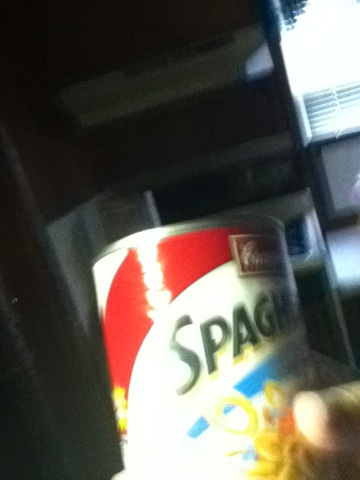Can you tell me more about the nutritional value of this canned spaghetti? Canned spaghetti typically contains carbohydrates from the pasta, some proteins, and fats. Additionally, it is usually rich in vitamins such as Vitamin A and Vitamin C, and minerals like iron and calcium. However, it may also contain added sugars and preservatives. Checking the nutritional label on the can will provide a detailed breakdown of these values.  What meals can I create using this canned spaghetti? You can use canned spaghetti in various meals! Some ideas include: 
1. Spaghetti and Meatballs: heat the canned spaghetti, add pre-made or homemade meatballs, and serve. 
2. Spaghetti Casserole: layer the canned spaghetti with cheese, vegetables, and perhaps some pre-cooked chicken or beef, then bake until bubbly. 
3. Spaghetti Pizza: spread the canned spaghetti over pizza dough, top with shredded cheese and your favorite pizza toppings, then bake. 
These are just a few ideas to get started!  Imagine this can of spaghetti became the main ingredient in a gourmet dish at a high-end restaurant. Describe the dish. In a high-end restaurant, a can of spaghetti could be transformed into a gourmet dish called 'Deconstructed Spaghetti Marinara.' The pasta would be delicately plated into a spiral, topped with an intricate marinara sauce reduction drizzle, and garnished with basil foam and shaved truffle. Accompanying the dish would be a small side of garlic confit, roasted cherry tomatoes, and a crisp parmesan tuile. The presentation would be impeccable, combining elegance with a hint of nostalgia. What if this can of spaghetti could talk? What stories might it share? If this can of spaghetti could talk, it might share stories of its journey from the field to the factory, and finally to your kitchen. It could tell of the farmers who grew the wheat for the pasta, the chefs who perfected the sauce recipe, and the factory workers who ensured it was safely canned. It might also share tales of the many families it has nourished, the excitement of being chosen from the store shelf, and the warm meals it helped create over the years. 